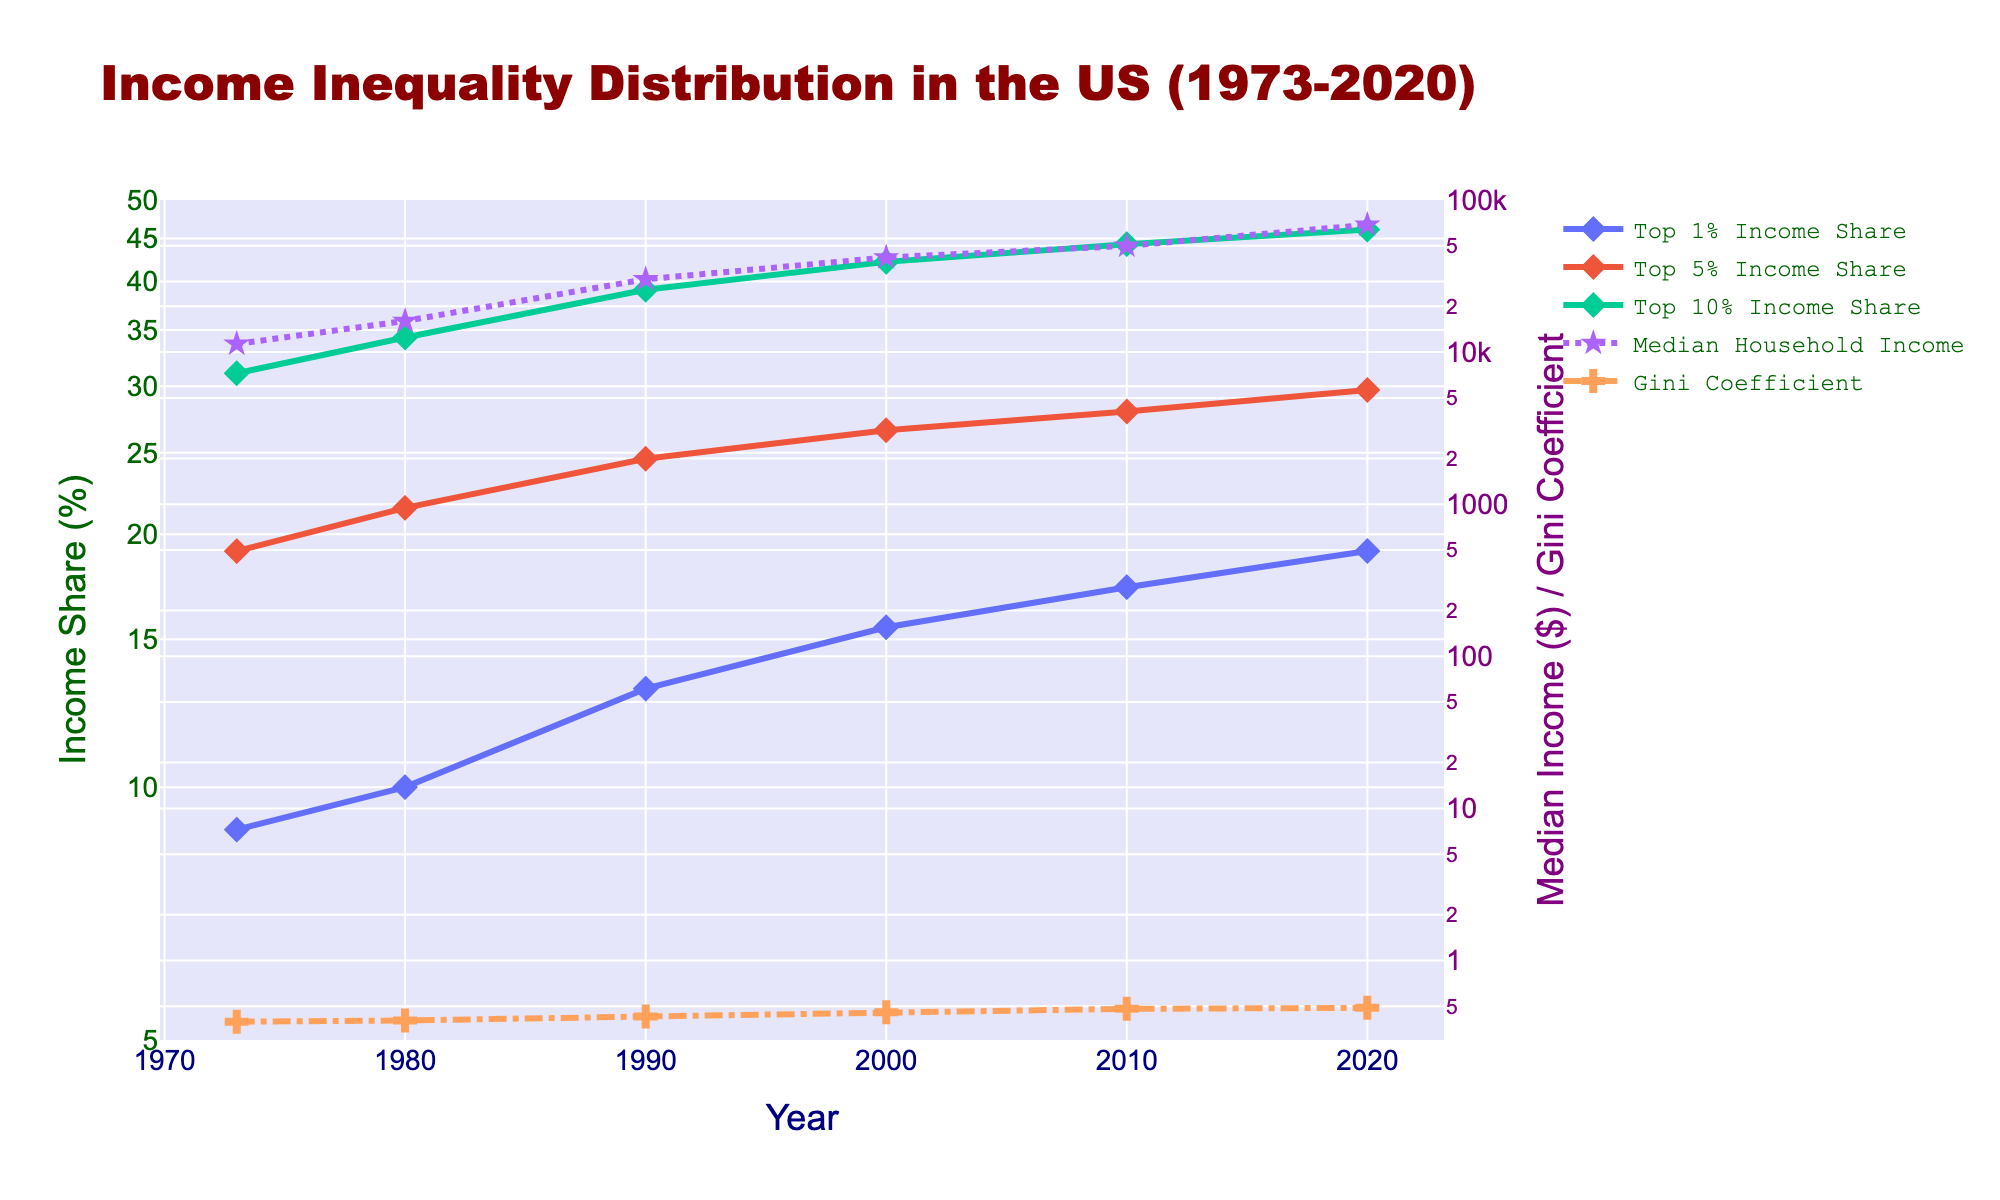What is the title of the plot? The title of the plot is located at the top of the figure and prominently framed, usually written in a larger or bold font for easy identification. It serves to inform the viewer about the subject matter or the main idea depicted in the figure.
Answer: Income Inequality Distribution in the US (1973-2020) What variables are shown on the primary y-axis (left y-axis)? The primary y-axis (left y-axis) includes variables that relate to income share expressed in percentages. This axis typically represents the proportion of income captured by different income groups over the given years, which can be found on the vertical scale to the left of the plot.
Answer: Income Share (%) What is the value range for the Gini Coefficient in 1973 and 2020? To determine this, look at the Gini Coefficient data points in the plot and observe their positions on the vertical axis. Use the secondary y-axis (right y-axis) to approximate their values in the specified years (1973 and 2020).
Answer: 0.396 in 1973, 0.488 in 2020 Which year shows the lowest median household income? To find this, locate the trace that represents the Median Household Income on the plot. Compare the values across different years and identify the year with the lowest point on the primary y-axis.
Answer: 1973 How much did the Top 1% Income Share increase from 1973 to 2020? Identify the data points for the Top 1% Income Share in 1973 and 2020 on the plot. Subtract the 1973 value from the 2020 value to calculate the increase.
Answer: 10.2% What trend can be observed in the Top 10% Income Share over the 50 years? Examine the trace representing the Top 10% Income Share and observe the general direction and behavior of the curve over the years. Look for patterns such as increasing, decreasing, or steady trends.
Answer: Increasing trend How does the line style differ for the Median Household Income and the Gini Coefficient? Observe the plot and notice the distinct line styles used for different variables. Specifically, compare the line style for the Median Household Income and the Gini Coefficient to distinguish between them.
Answer: Median Household Income has a dotted line; Gini Coefficient has a dash-dot line Between 1980 and 2000, which experienced a larger increase in share: Top 1% Income Share or Top 5% Income Share? Identify the values for both the Top 1% and Top 5% Income Shares in the years 1980 and 2000. Calculate the increase for each variable by subtracting the 1980 value from the 2000 value and compare them.
Answer: Top 1% Income Share Did the Median Household Income ever exceed $50,000? If so, in which year(s)? Check the trace for the Median Household Income and look for data points that are higher than $50,000. Note the specific years where this occurs.
Answer: 2010, 2020 